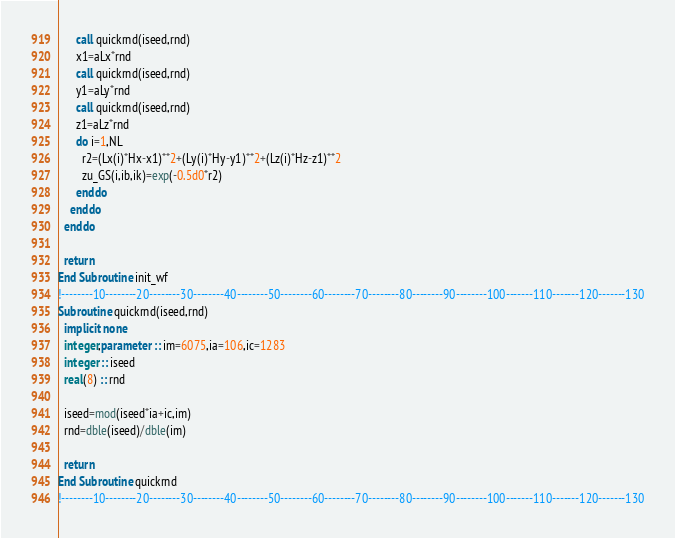Convert code to text. <code><loc_0><loc_0><loc_500><loc_500><_FORTRAN_>      call quickrnd(iseed,rnd)
      x1=aLx*rnd
      call quickrnd(iseed,rnd)
      y1=aLy*rnd
      call quickrnd(iseed,rnd)
      z1=aLz*rnd
      do i=1,NL
        r2=(Lx(i)*Hx-x1)**2+(Ly(i)*Hy-y1)**2+(Lz(i)*Hz-z1)**2
        zu_GS(i,ib,ik)=exp(-0.5d0*r2)
      enddo
    enddo
  enddo

  return
End Subroutine init_wf
!--------10--------20--------30--------40--------50--------60--------70--------80--------90--------100-------110-------120-------130
Subroutine quickrnd(iseed,rnd)
  implicit none
  integer,parameter :: im=6075,ia=106,ic=1283
  integer :: iseed
  real(8) :: rnd

  iseed=mod(iseed*ia+ic,im)
  rnd=dble(iseed)/dble(im)

  return
End Subroutine quickrnd
!--------10--------20--------30--------40--------50--------60--------70--------80--------90--------100-------110-------120-------130

</code> 